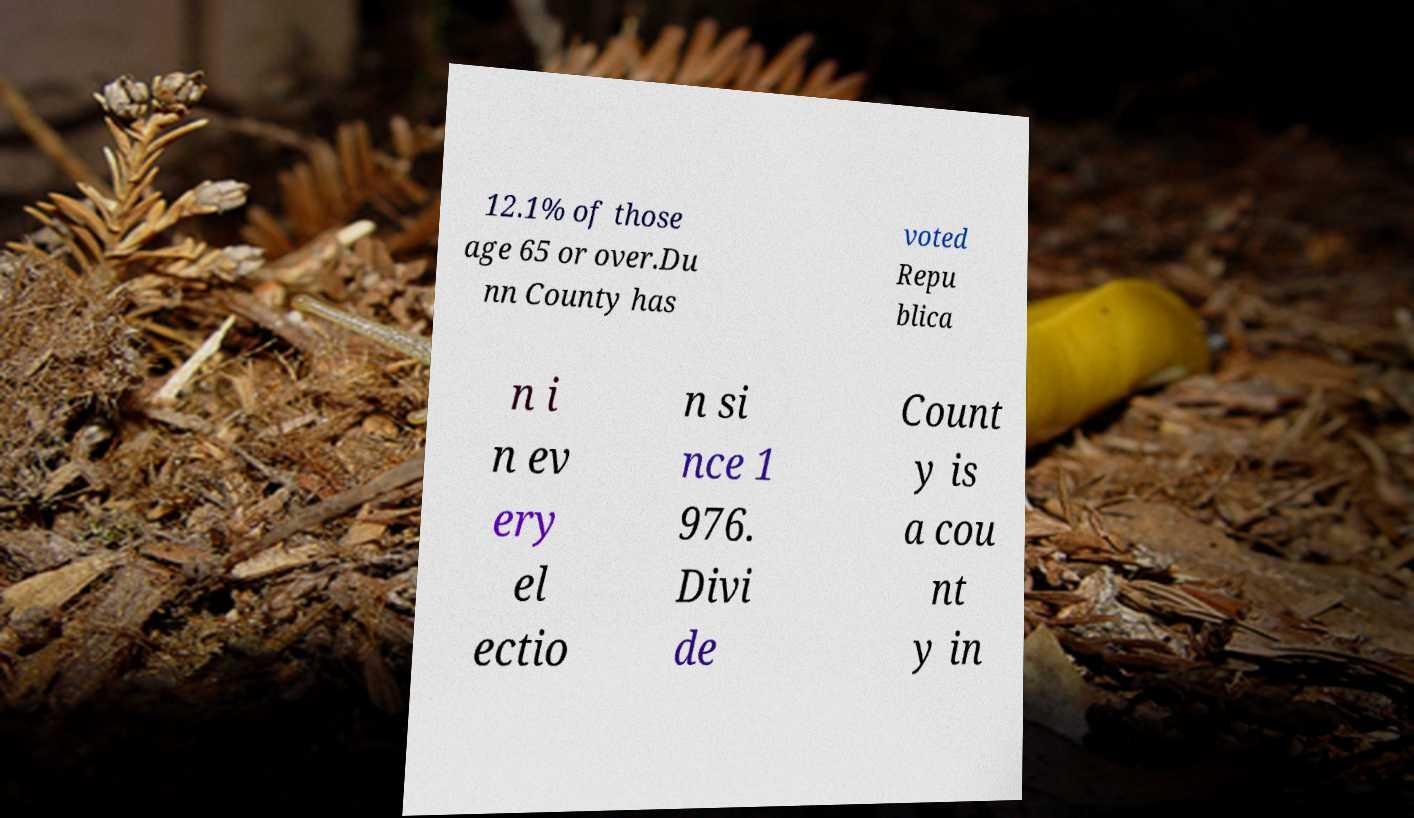For documentation purposes, I need the text within this image transcribed. Could you provide that? 12.1% of those age 65 or over.Du nn County has voted Repu blica n i n ev ery el ectio n si nce 1 976. Divi de Count y is a cou nt y in 